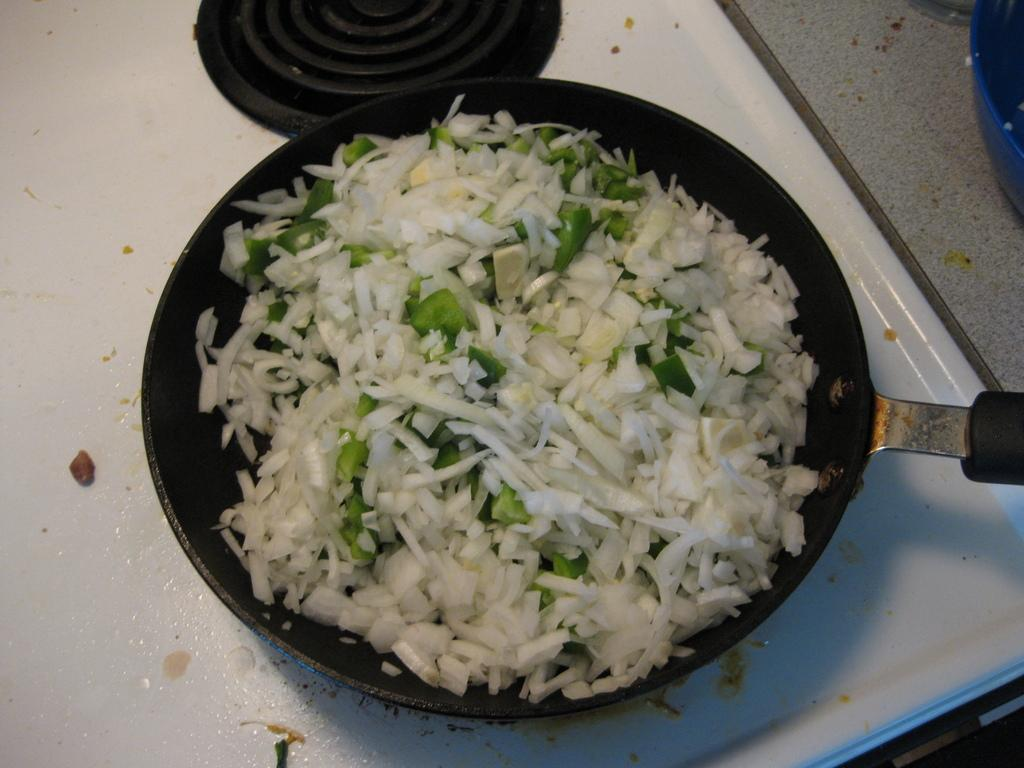What type of food is in the pan in the image? There are vegetables in a black color pan in the image. What is the color of the desk where the pan is placed? The pan is placed on a white color desk. Can you describe the cooking appliance in the image? There is a stove in the image. What type of riddle can be solved using the vegetables in the image? There is no riddle present in the image, nor is there any indication that the vegetables can be used to solve a riddle. 